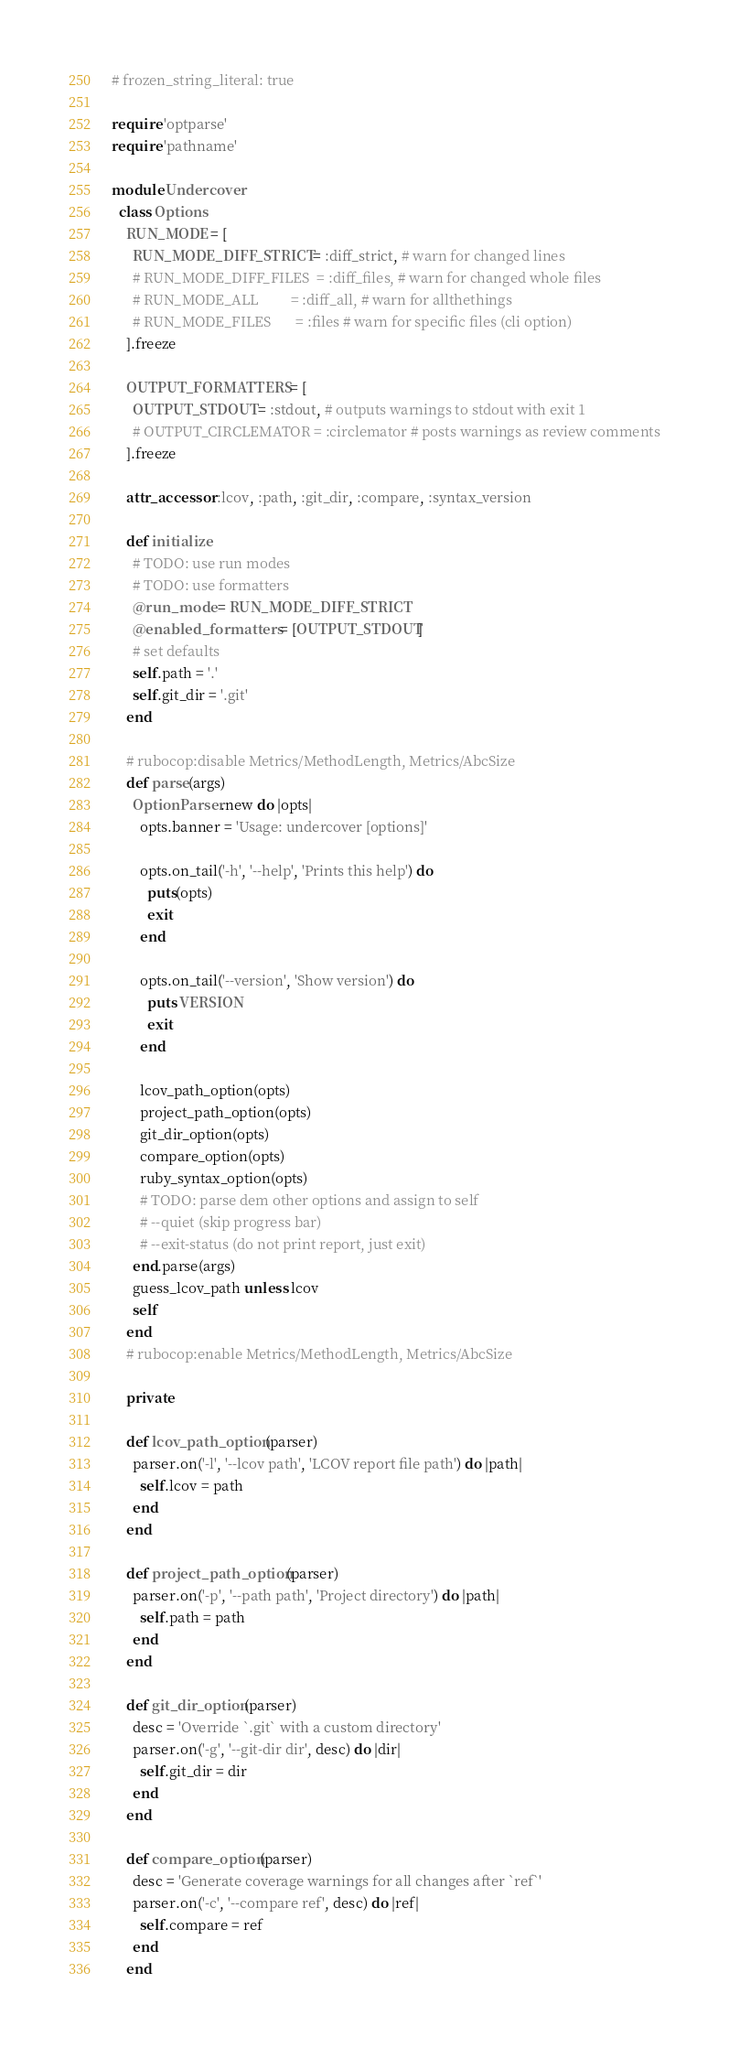Convert code to text. <code><loc_0><loc_0><loc_500><loc_500><_Ruby_># frozen_string_literal: true

require 'optparse'
require 'pathname'

module Undercover
  class Options
    RUN_MODE = [
      RUN_MODE_DIFF_STRICT = :diff_strict, # warn for changed lines
      # RUN_MODE_DIFF_FILES  = :diff_files, # warn for changed whole files
      # RUN_MODE_ALL         = :diff_all, # warn for allthethings
      # RUN_MODE_FILES       = :files # warn for specific files (cli option)
    ].freeze

    OUTPUT_FORMATTERS = [
      OUTPUT_STDOUT = :stdout, # outputs warnings to stdout with exit 1
      # OUTPUT_CIRCLEMATOR = :circlemator # posts warnings as review comments
    ].freeze

    attr_accessor :lcov, :path, :git_dir, :compare, :syntax_version

    def initialize
      # TODO: use run modes
      # TODO: use formatters
      @run_mode = RUN_MODE_DIFF_STRICT
      @enabled_formatters = [OUTPUT_STDOUT]
      # set defaults
      self.path = '.'
      self.git_dir = '.git'
    end

    # rubocop:disable Metrics/MethodLength, Metrics/AbcSize
    def parse(args)
      OptionParser.new do |opts|
        opts.banner = 'Usage: undercover [options]'

        opts.on_tail('-h', '--help', 'Prints this help') do
          puts(opts)
          exit
        end

        opts.on_tail('--version', 'Show version') do
          puts VERSION
          exit
        end

        lcov_path_option(opts)
        project_path_option(opts)
        git_dir_option(opts)
        compare_option(opts)
        ruby_syntax_option(opts)
        # TODO: parse dem other options and assign to self
        # --quiet (skip progress bar)
        # --exit-status (do not print report, just exit)
      end.parse(args)
      guess_lcov_path unless lcov
      self
    end
    # rubocop:enable Metrics/MethodLength, Metrics/AbcSize

    private

    def lcov_path_option(parser)
      parser.on('-l', '--lcov path', 'LCOV report file path') do |path|
        self.lcov = path
      end
    end

    def project_path_option(parser)
      parser.on('-p', '--path path', 'Project directory') do |path|
        self.path = path
      end
    end

    def git_dir_option(parser)
      desc = 'Override `.git` with a custom directory'
      parser.on('-g', '--git-dir dir', desc) do |dir|
        self.git_dir = dir
      end
    end

    def compare_option(parser)
      desc = 'Generate coverage warnings for all changes after `ref`'
      parser.on('-c', '--compare ref', desc) do |ref|
        self.compare = ref
      end
    end
</code> 